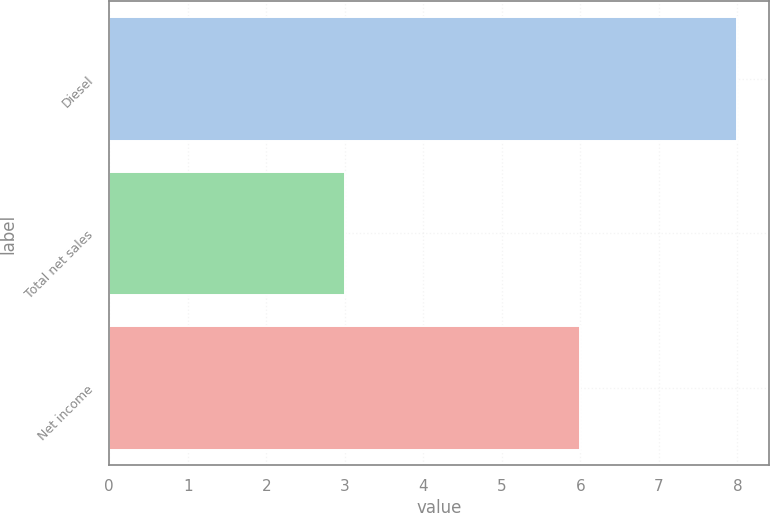<chart> <loc_0><loc_0><loc_500><loc_500><bar_chart><fcel>Diesel<fcel>Total net sales<fcel>Net income<nl><fcel>8<fcel>3<fcel>6<nl></chart> 